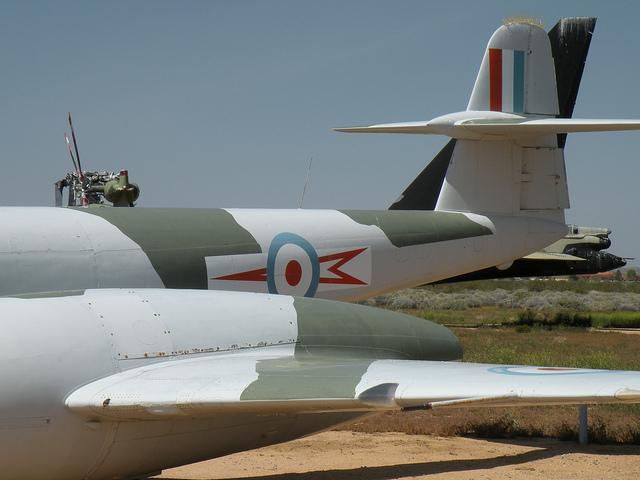How many airplanes are there?
Give a very brief answer. 3. How many cars are heading toward the train?
Give a very brief answer. 0. 